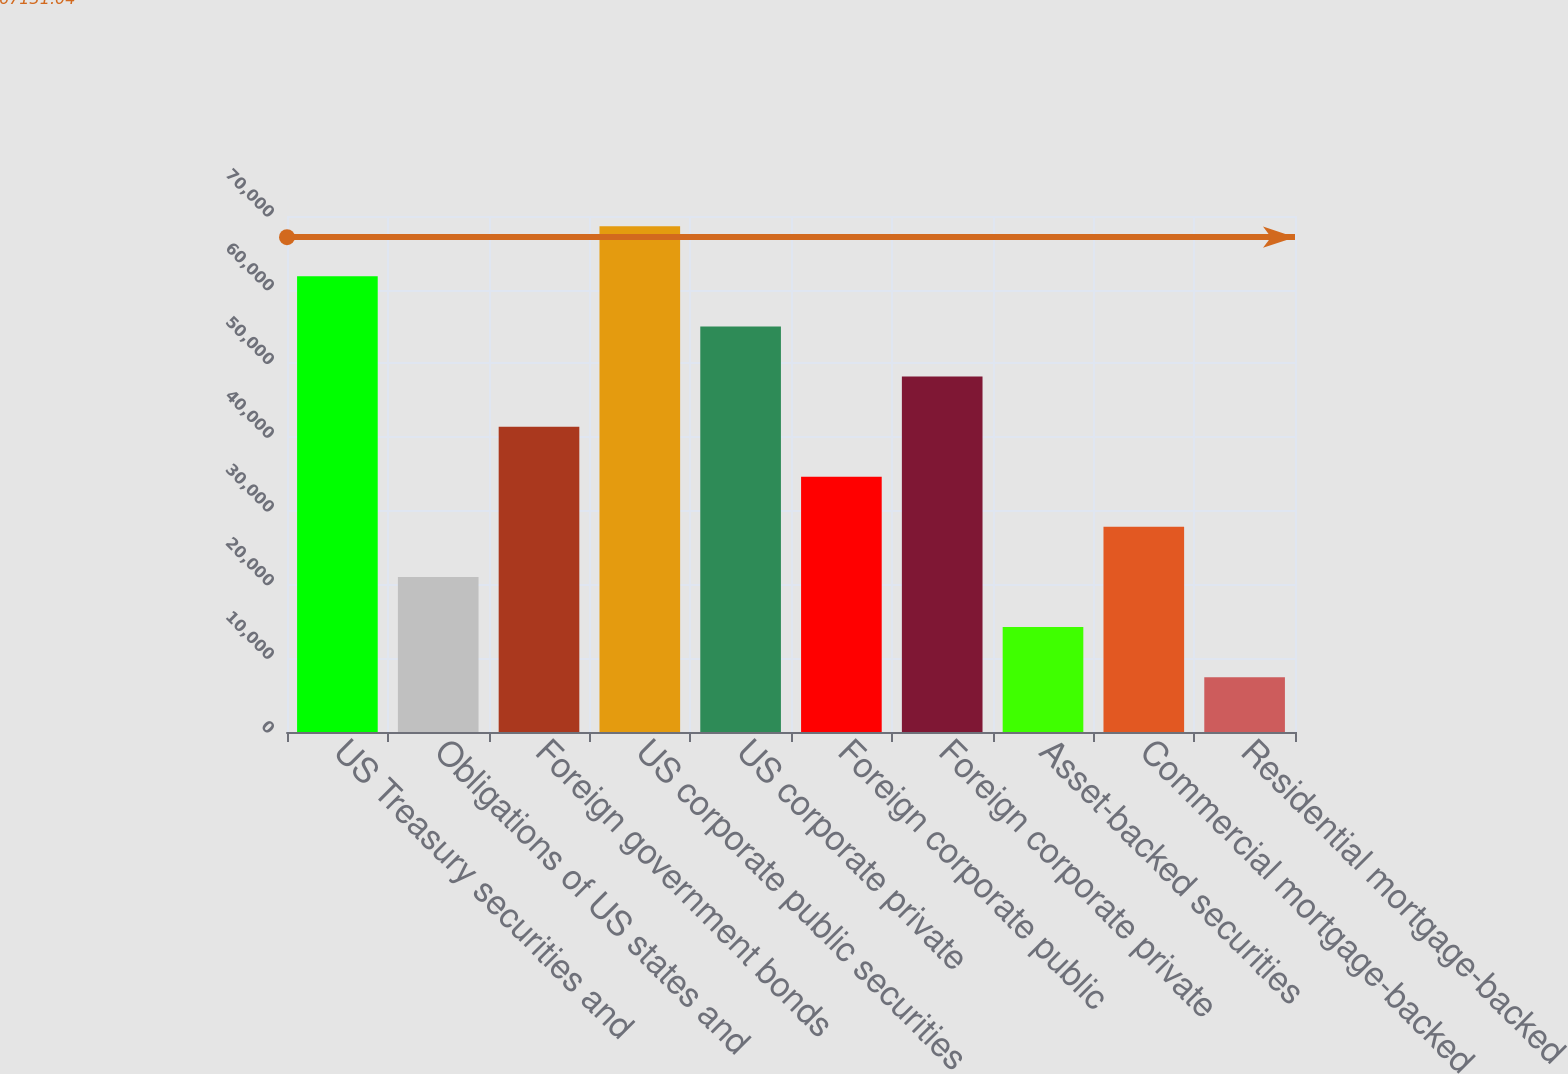<chart> <loc_0><loc_0><loc_500><loc_500><bar_chart><fcel>US Treasury securities and<fcel>Obligations of US states and<fcel>Foreign government bonds<fcel>US corporate public securities<fcel>US corporate private<fcel>Foreign corporate public<fcel>Foreign corporate private<fcel>Asset-backed securities<fcel>Commercial mortgage-backed<fcel>Residential mortgage-backed<nl><fcel>61815.4<fcel>21029.8<fcel>41422.6<fcel>68613<fcel>55017.8<fcel>34625<fcel>48220.2<fcel>14232.2<fcel>27827.4<fcel>7434.6<nl></chart> 